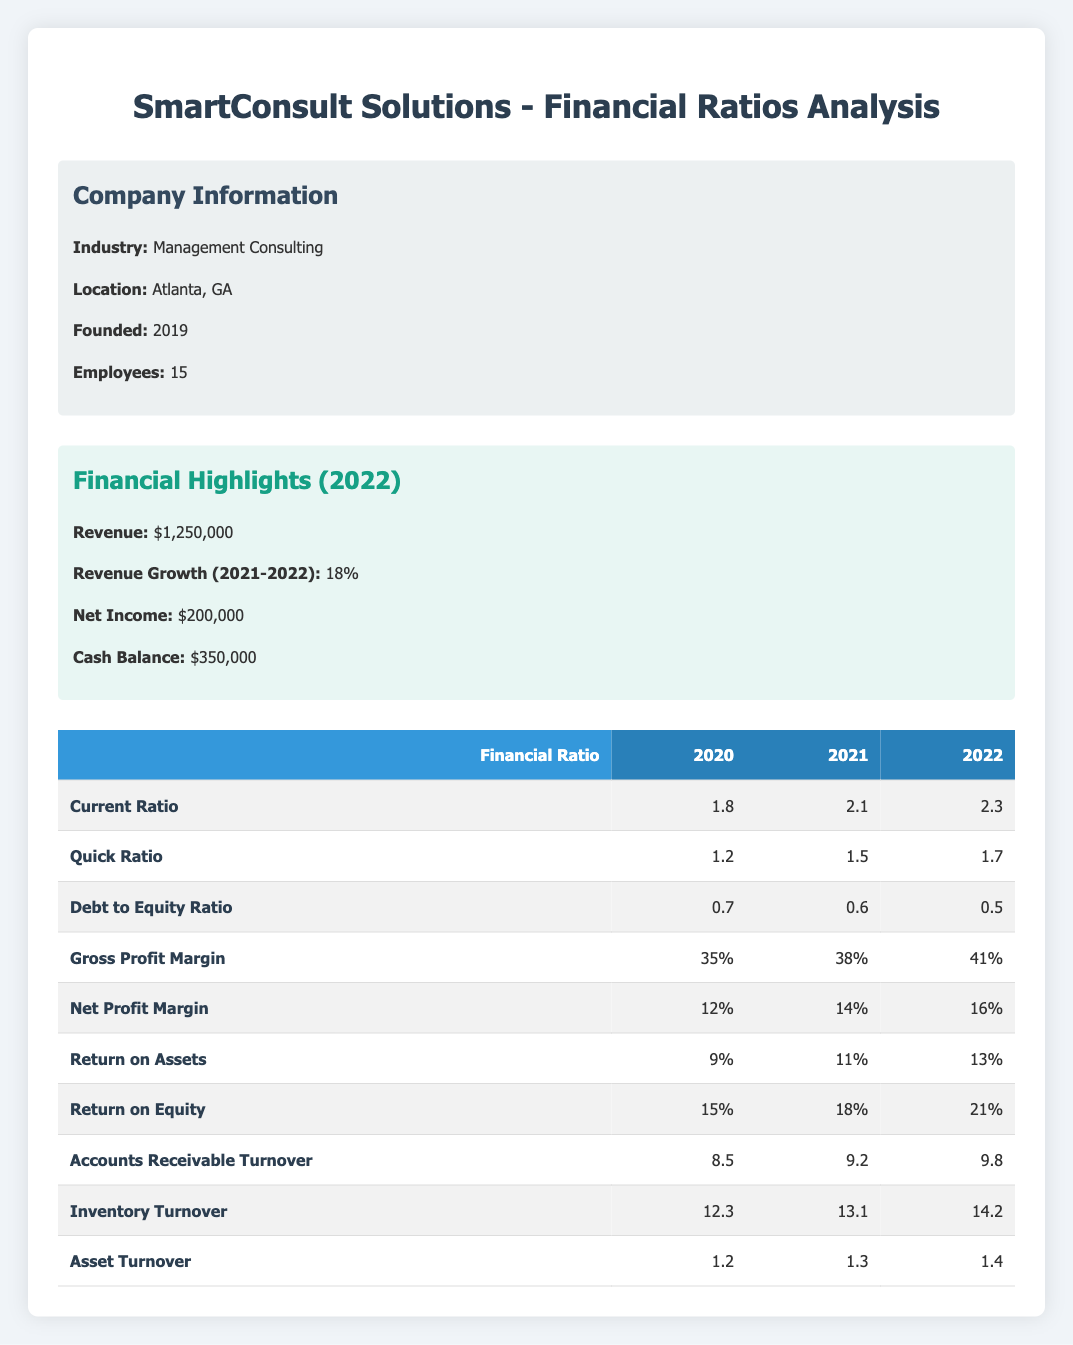What is the current ratio for the year 2021? The current ratio for 2021 can be found in the table under the appropriate column for that year. It shows a value of 2.1.
Answer: 2.1 What is the quick ratio for the year 2022? To find the quick ratio for 2022, we look at the corresponding year column in the table, which indicates the value is 1.7.
Answer: 1.7 Is the debt to equity ratio showing a declining trend over the years? By comparing the debt to equity ratios from the years 2020 (0.7), 2021 (0.6), and 2022 (0.5), we can see that the values are decreasing each year, indicating a declining trend.
Answer: Yes What is the net profit margin for the year 2020 and how does it compare to that of 2022? The net profit margin for 2020 is 12%, and for 2022 it is 16%. Comparing these values, we see that the net profit margin has increased by 4 percentage points from 2020 to 2022.
Answer: 12% (2020), Increased to 16% (2022) What is the total increase in return on equity from 2020 to 2022? The return on equity for 2020 is 15% and for 2022, it is 21%. The increase can be calculated by subtracting 15% from 21%, resulting in an increase of 6 percentage points over the two years.
Answer: 6 percentage points What was the average gross profit margin over the three years? The gross profit margins are 35% for 2020, 38% for 2021, and 41% for 2022. To find the average, we add these values: 35 + 38 + 41 = 114. Then divide by 3 (the number of years), which gives 114/3 = 38%.
Answer: 38% Did SmartConsult Solutions have a higher accounts receivable turnover in 2022 compared to 2020? Checking the values in the table, the accounts receivable turnover is 8.5 for 2020 and 9.8 for 2022. Since 9.8 is greater than 8.5, it indicates that the company improved its accounts receivable turnover.
Answer: Yes How much did the cash balance change from 2021 to 2022? The cash balance is provided for 2022 as $350,000, but there is no cash balance stated for 2021 in the data provided. Thus, we cannot determine a change in cash balance simply from the available information.
Answer: Not determinable What is the highest inventory turnover ratio recorded in the three years? We check the inventory turnover for each year listed in the table: 12.3 for 2020, 13.1 for 2021, and 14.2 for 2022. Among these, the highest value is 14.2 for the year 2022.
Answer: 14.2 (2022) 